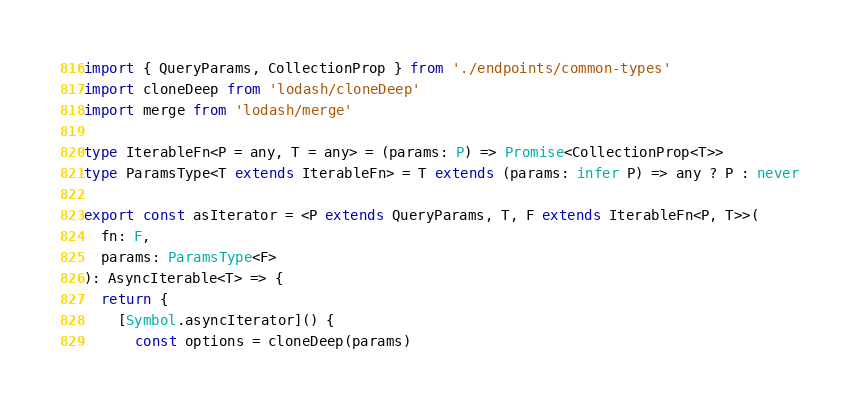<code> <loc_0><loc_0><loc_500><loc_500><_TypeScript_>import { QueryParams, CollectionProp } from './endpoints/common-types'
import cloneDeep from 'lodash/cloneDeep'
import merge from 'lodash/merge'

type IterableFn<P = any, T = any> = (params: P) => Promise<CollectionProp<T>>
type ParamsType<T extends IterableFn> = T extends (params: infer P) => any ? P : never

export const asIterator = <P extends QueryParams, T, F extends IterableFn<P, T>>(
  fn: F,
  params: ParamsType<F>
): AsyncIterable<T> => {
  return {
    [Symbol.asyncIterator]() {
      const options = cloneDeep(params)</code> 